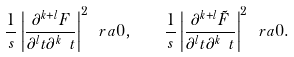Convert formula to latex. <formula><loc_0><loc_0><loc_500><loc_500>\frac { 1 } { s } \left | \frac { \partial ^ { k + l } { F } } { \partial ^ { l } { t } \partial ^ { k } { \ t } } \right | ^ { 2 } \ r a 0 , \quad \frac { 1 } { s } \left | \frac { \partial ^ { k + l } { \tilde { F } } } { \partial ^ { l } { t } \partial ^ { k } { \ t } } \right | ^ { 2 } \ r a 0 .</formula> 